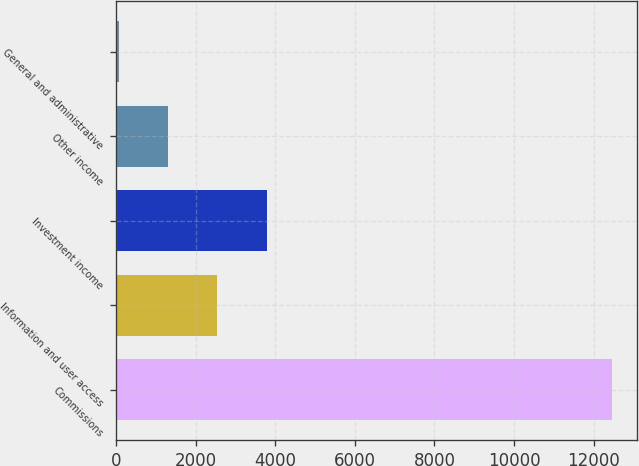Convert chart. <chart><loc_0><loc_0><loc_500><loc_500><bar_chart><fcel>Commissions<fcel>Information and user access<fcel>Investment income<fcel>Other income<fcel>General and administrative<nl><fcel>12466<fcel>2538.8<fcel>3779.7<fcel>1297.9<fcel>57<nl></chart> 